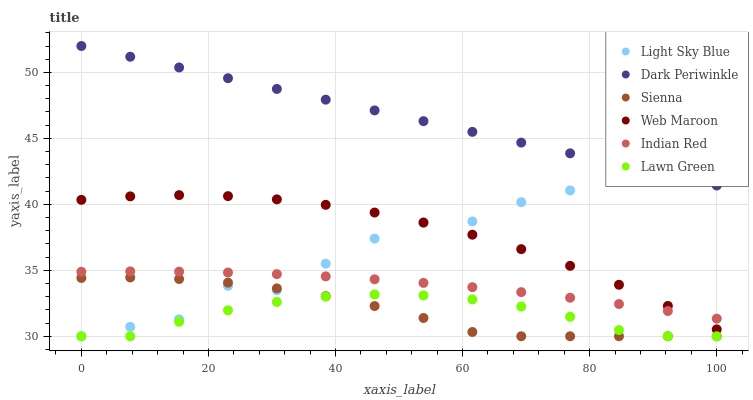Does Lawn Green have the minimum area under the curve?
Answer yes or no. Yes. Does Dark Periwinkle have the maximum area under the curve?
Answer yes or no. Yes. Does Web Maroon have the minimum area under the curve?
Answer yes or no. No. Does Web Maroon have the maximum area under the curve?
Answer yes or no. No. Is Dark Periwinkle the smoothest?
Answer yes or no. Yes. Is Light Sky Blue the roughest?
Answer yes or no. Yes. Is Web Maroon the smoothest?
Answer yes or no. No. Is Web Maroon the roughest?
Answer yes or no. No. Does Lawn Green have the lowest value?
Answer yes or no. Yes. Does Web Maroon have the lowest value?
Answer yes or no. No. Does Dark Periwinkle have the highest value?
Answer yes or no. Yes. Does Web Maroon have the highest value?
Answer yes or no. No. Is Sienna less than Dark Periwinkle?
Answer yes or no. Yes. Is Web Maroon greater than Lawn Green?
Answer yes or no. Yes. Does Web Maroon intersect Light Sky Blue?
Answer yes or no. Yes. Is Web Maroon less than Light Sky Blue?
Answer yes or no. No. Is Web Maroon greater than Light Sky Blue?
Answer yes or no. No. Does Sienna intersect Dark Periwinkle?
Answer yes or no. No. 